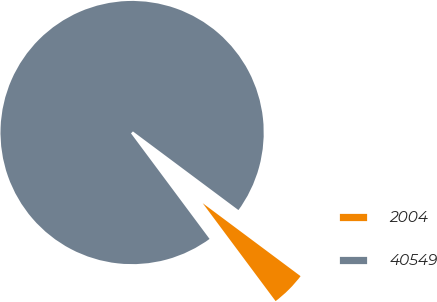Convert chart to OTSL. <chart><loc_0><loc_0><loc_500><loc_500><pie_chart><fcel>2004<fcel>40549<nl><fcel>4.62%<fcel>95.38%<nl></chart> 